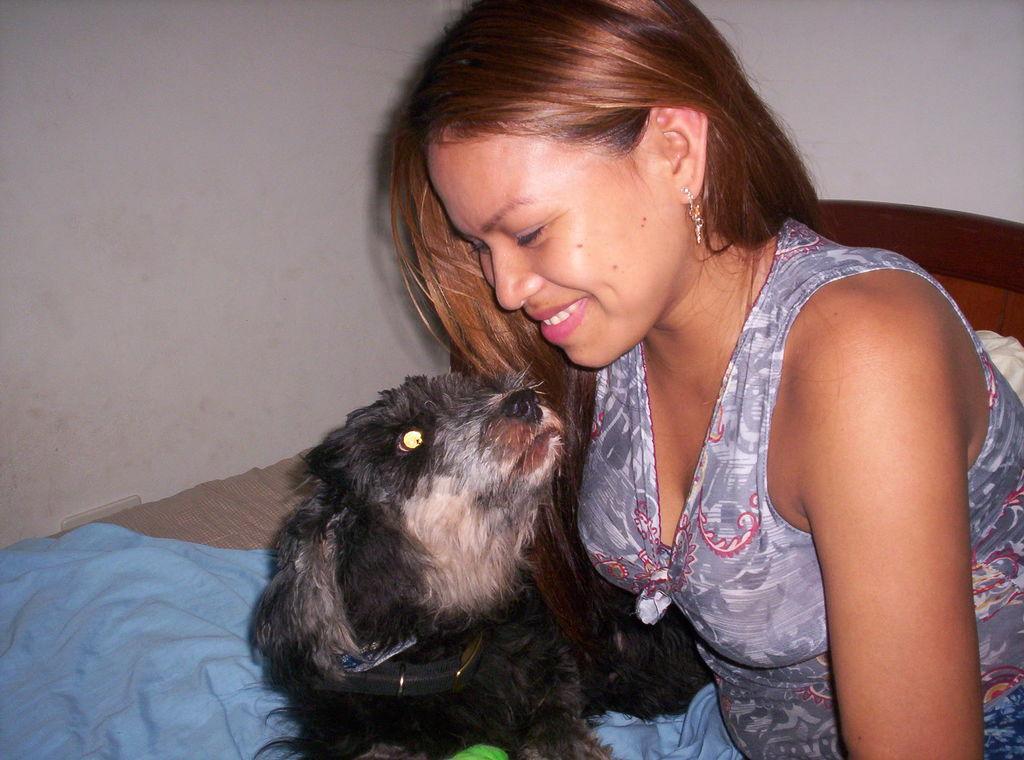Can you describe this image briefly? In this image, women in ash color dress. Beside her, there is a black color dog. Here we can see bed, blue color cloth and white color wall. 